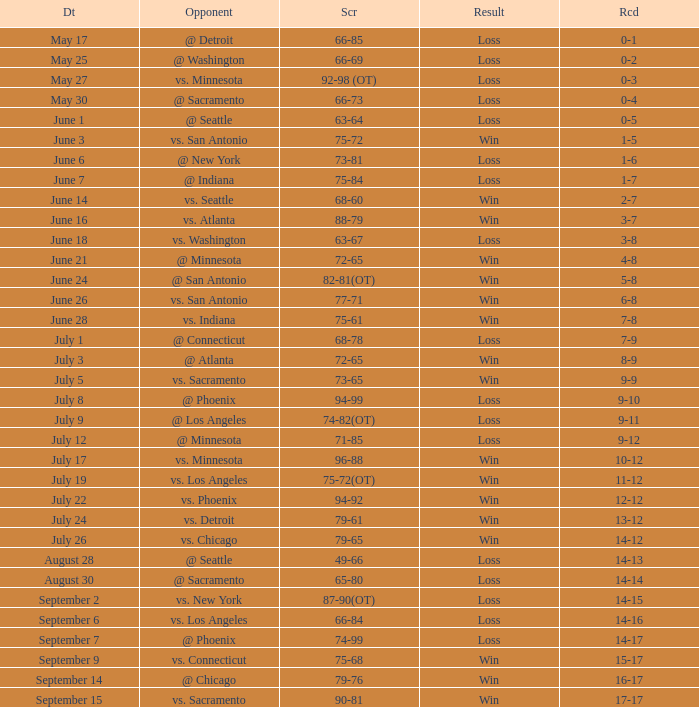What is the Record of the game on June 24? 5-8. 